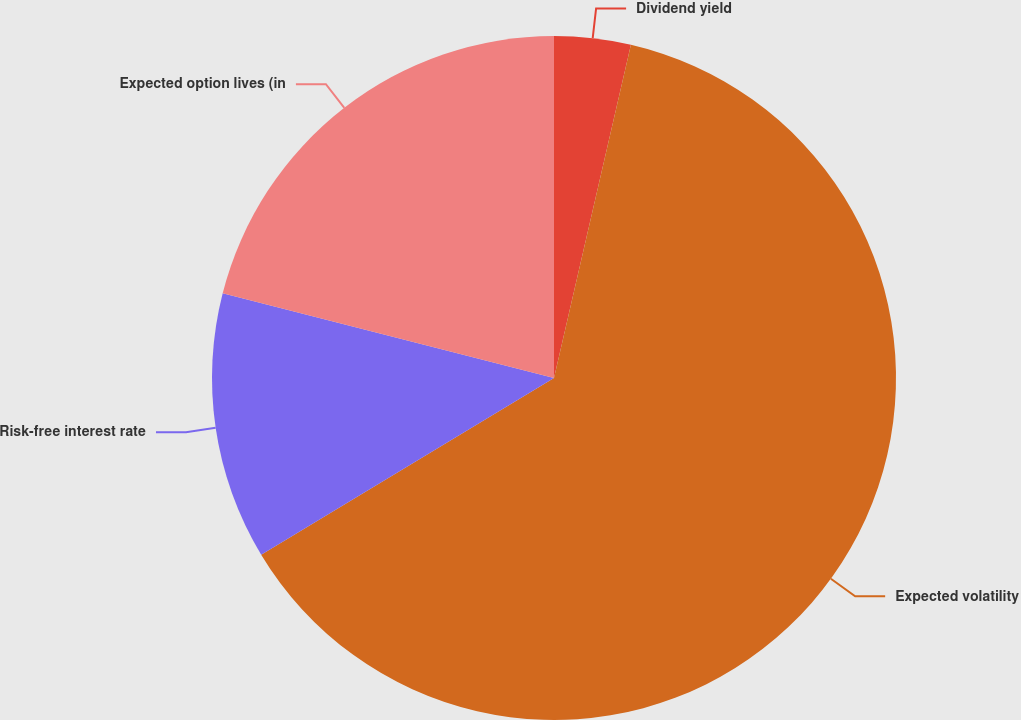<chart> <loc_0><loc_0><loc_500><loc_500><pie_chart><fcel>Dividend yield<fcel>Expected volatility<fcel>Risk-free interest rate<fcel>Expected option lives (in<nl><fcel>3.61%<fcel>62.75%<fcel>12.63%<fcel>21.01%<nl></chart> 